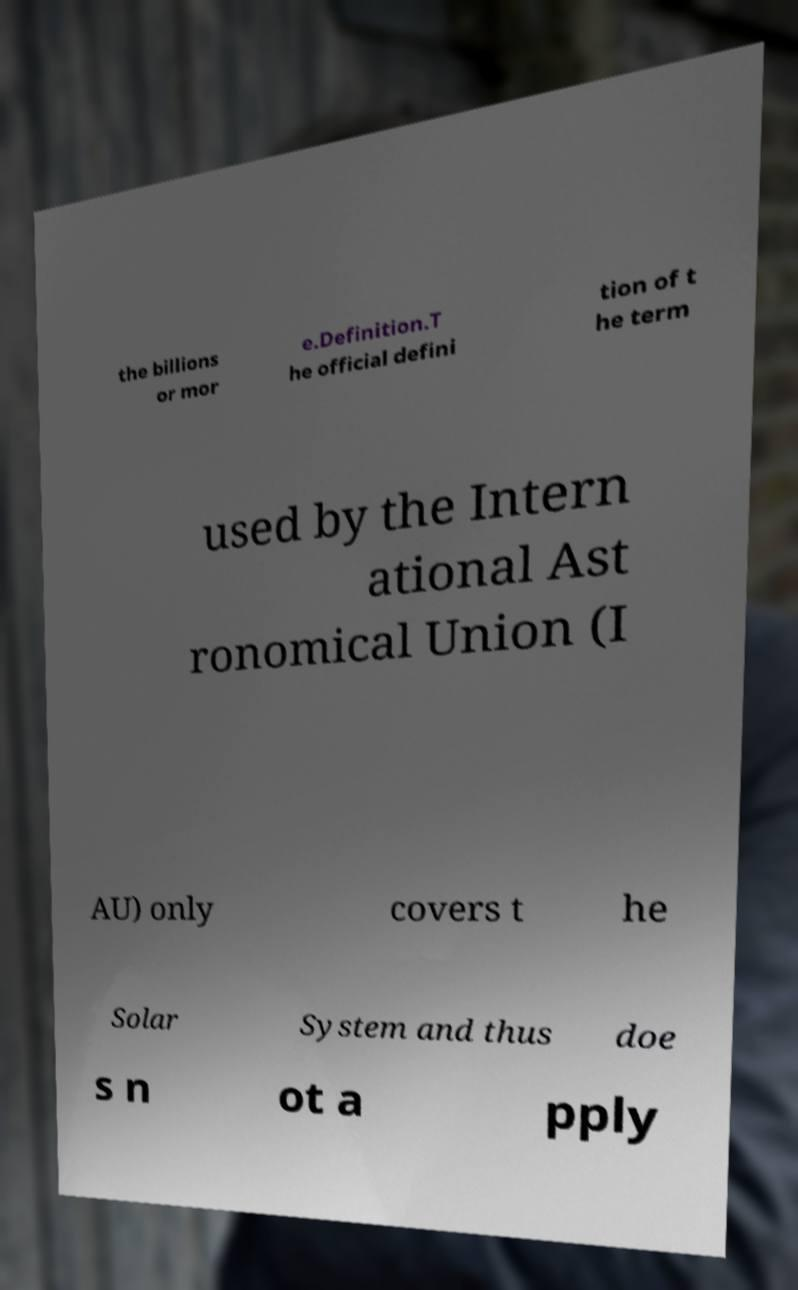Can you read and provide the text displayed in the image?This photo seems to have some interesting text. Can you extract and type it out for me? the billions or mor e.Definition.T he official defini tion of t he term used by the Intern ational Ast ronomical Union (I AU) only covers t he Solar System and thus doe s n ot a pply 